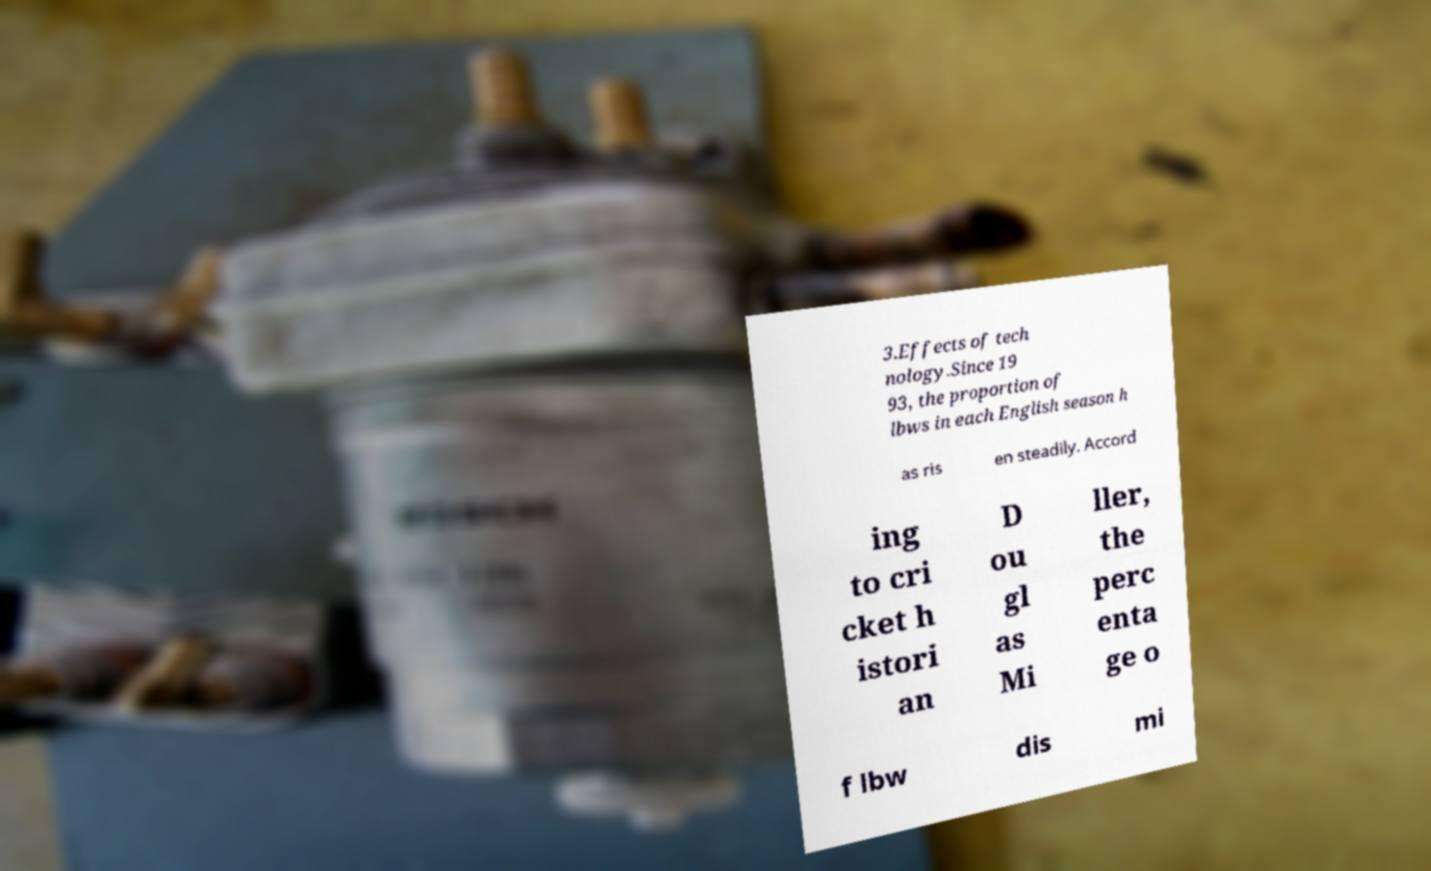For documentation purposes, I need the text within this image transcribed. Could you provide that? 3.Effects of tech nology.Since 19 93, the proportion of lbws in each English season h as ris en steadily. Accord ing to cri cket h istori an D ou gl as Mi ller, the perc enta ge o f lbw dis mi 